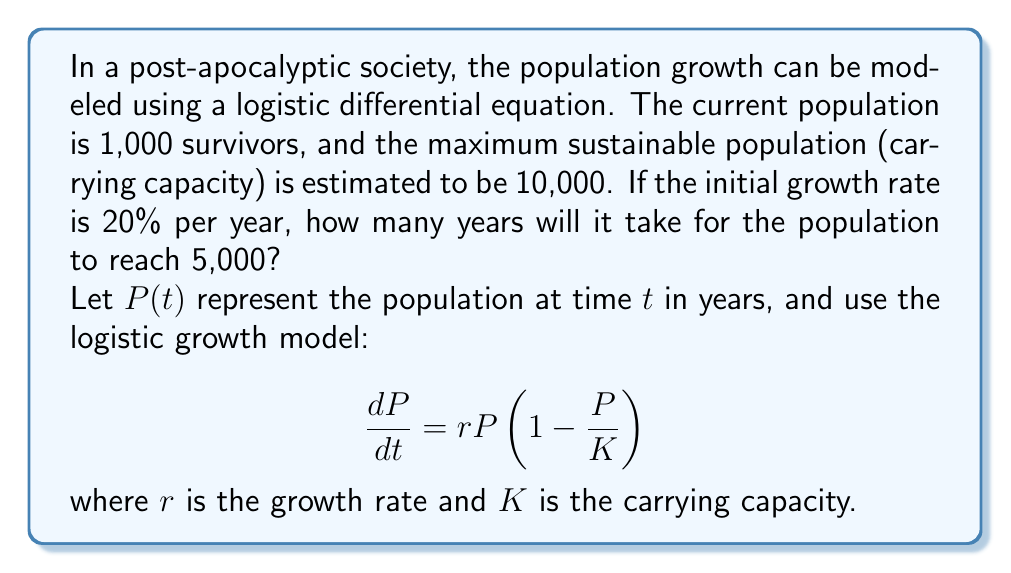Teach me how to tackle this problem. To solve this problem, we'll follow these steps:

1) First, we need to set up our logistic differential equation with the given values:
   $r = 0.2$ (20% growth rate)
   $K = 10,000$ (carrying capacity)
   $P(0) = 1,000$ (initial population)

   $$\frac{dP}{dt} = 0.2P(1-\frac{P}{10000})$$

2) The solution to this logistic differential equation is:

   $$P(t) = \frac{K}{1 + (\frac{K}{P_0} - 1)e^{-rt}}$$

   where $P_0$ is the initial population.

3) Substituting our values:

   $$P(t) = \frac{10000}{1 + (\frac{10000}{1000} - 1)e^{-0.2t}}$$

4) We want to find $t$ when $P(t) = 5000$. So, let's set up the equation:

   $$5000 = \frac{10000}{1 + 9e^{-0.2t}}$$

5) Solving for $t$:
   
   $$1 + 9e^{-0.2t} = 2$$
   $$9e^{-0.2t} = 1$$
   $$e^{-0.2t} = \frac{1}{9}$$
   $$-0.2t = \ln(\frac{1}{9})$$
   $$t = -\frac{1}{0.2}\ln(\frac{1}{9}) = 5\ln(9) \approx 11.0252$$

Therefore, it will take approximately 11.03 years for the population to reach 5,000.
Answer: $t \approx 11.03$ years 